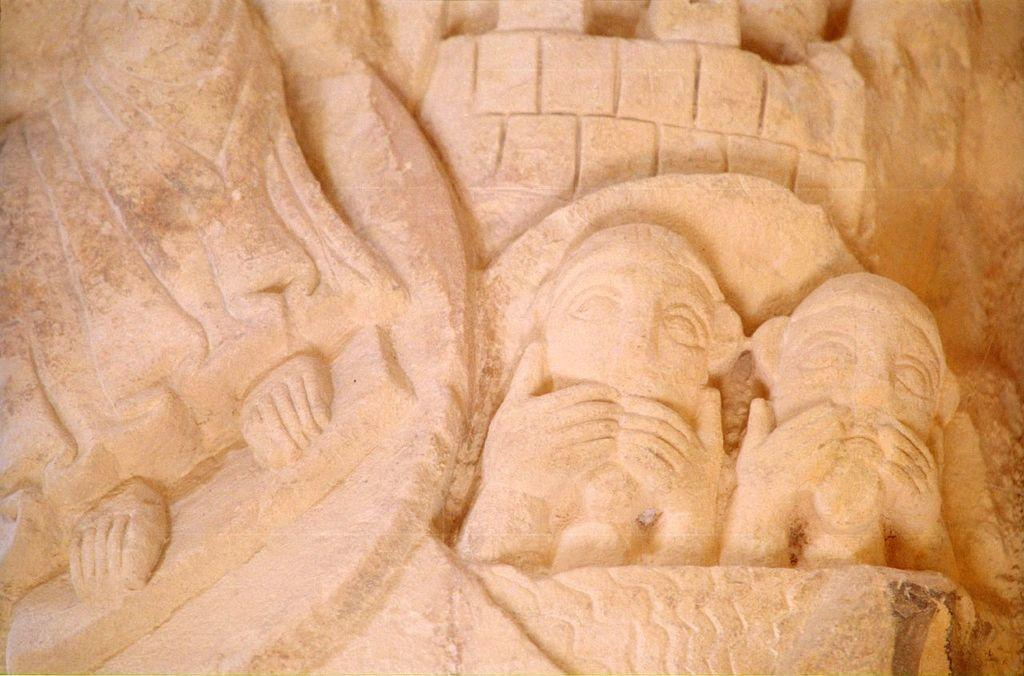What type of artwork can be seen on the wall in the image? There is a stone carving on the wall in the image. Can you describe the medium of the artwork? The artwork is a stone carving, which means it is carved into stone. What is the location of the artwork in the image? The stone carving is on a wall in the image. What type of boot is hanging on the side of the wall in the image? There is no boot present in the image; it only features a stone carving on the wall. 